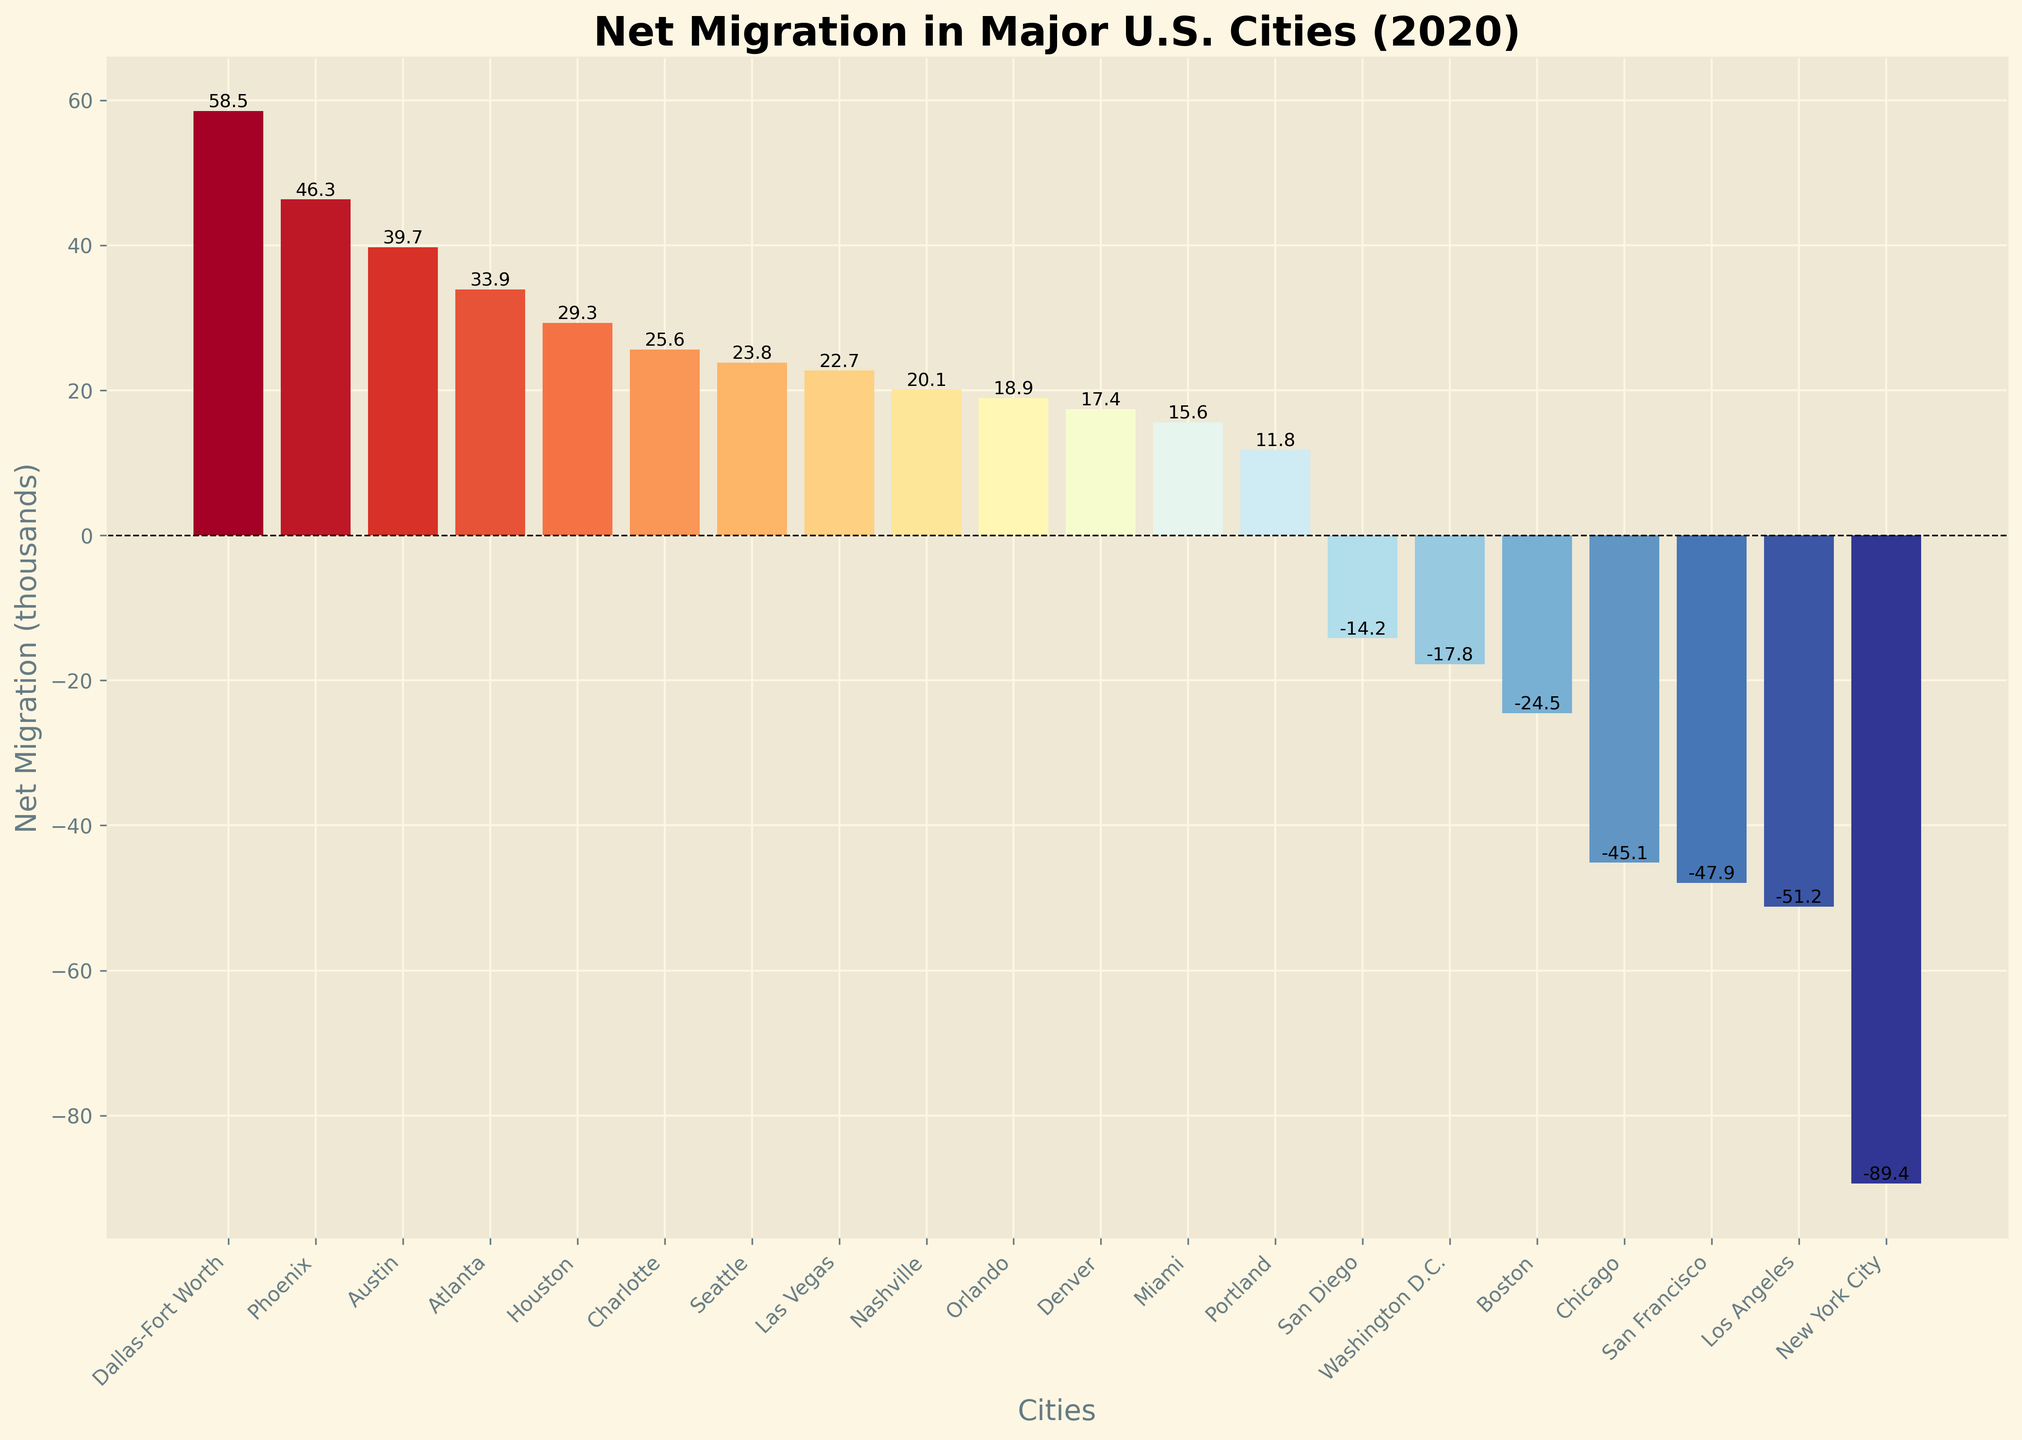Which city experienced the highest net migration in 2020? By looking at the heights of the bars, the tallest bar represents the city with the highest net migration. Dallas-Fort Worth has the highest positive net migration.
Answer: Dallas-Fort Worth Which city experienced the lowest net migration in 2020? By looking at the heights of the bars, the shortest bar (or the most negative one) represents the city with the lowest net migration. New York City has the lowest net migration.
Answer: New York City What is the combined net migration for Dallas-Fort Worth and Phoenix? Look at the net migration values for Dallas-Fort Worth and Phoenix, which are 58.5 and 46.3 respectively. Adding these values together gives 58.5 + 46.3 = 104.8 thousand.
Answer: 104.8 thousand How many cities experienced negative net migration in 2020? Count the bars below the horizontal line (y=0). There are 8 cities with net migrations below zero.
Answer: 8 Which two cities had net migrations closest to zero in 2020? Look for the bars that are nearest to the horizontal line (y=0). Washington D.C. with -17.8 and Portland with 11.8 are the closest to zero.
Answer: Washington D.C. and Portland Compare the net migration of Chicago and Austin; which one had higher net migration? Look at the heights of the bars for Chicago and Austin. Austin has a positive net migration of 39.7, whereas Chicago has a negative net migration of -45.1. Austin's net migration is higher.
Answer: Austin What is the average net migration of the cities with positive net migrations? Identify cities with positive net migrations and sum their values: Dallas-Fort Worth (58.5), Phoenix (46.3), Austin (39.7), Seattle (23.8), Miami (15.6), Houston (29.3), Denver (17.4), Atlanta (33.9), Nashville (20.1), Portland (11.8), Las Vegas (22.7), Charlotte (25.6), and Orlando (18.9). Adding these gives 363.6. Counting these cities gives 13. The average is 363.6 / 13 = 27.96.
Answer: 27.96 thousand Which city had a net migration just over 40 thousand? By looking at the heights and labels of the bars, Phoenix has a net migration of 46.3 thousand, which is just over 40 thousand.
Answer: Phoenix What regions had a net migration between 10 and 20 thousand? By looking at the heights and values of the bars: Denver (17.4), Nashville (20.1), Portland (11.8), and Orlando (18.9) all fall within the range of 10 to 20 thousand.
Answer: Denver, Nashville, Portland, Orlando 